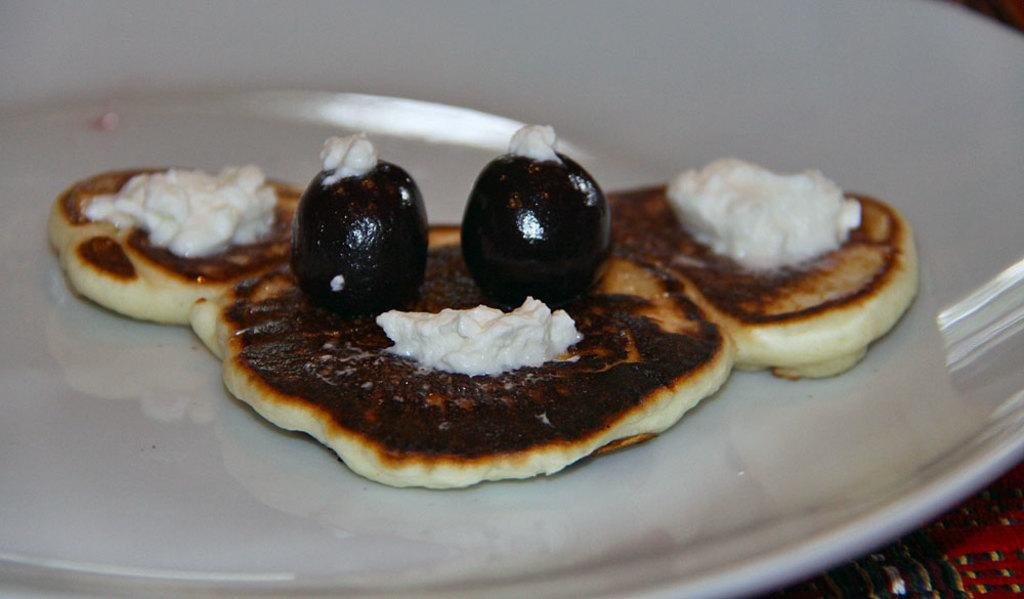What is present on the plate in the image? There are food items on the plate in the image. What is the color of the plate? The plate is white in color. Can you see any goats in the image? No, there are no goats present in the image. What type of salt is sprinkled on the food items on the plate? There is no salt visible on the food items in the image. 